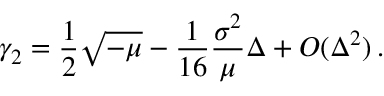Convert formula to latex. <formula><loc_0><loc_0><loc_500><loc_500>\gamma _ { 2 } = \frac { 1 } { 2 } \sqrt { - \mu } - \frac { 1 } { 1 6 } \frac { \sigma ^ { 2 } } { \mu } \Delta + O ( \Delta ^ { 2 } ) \, .</formula> 